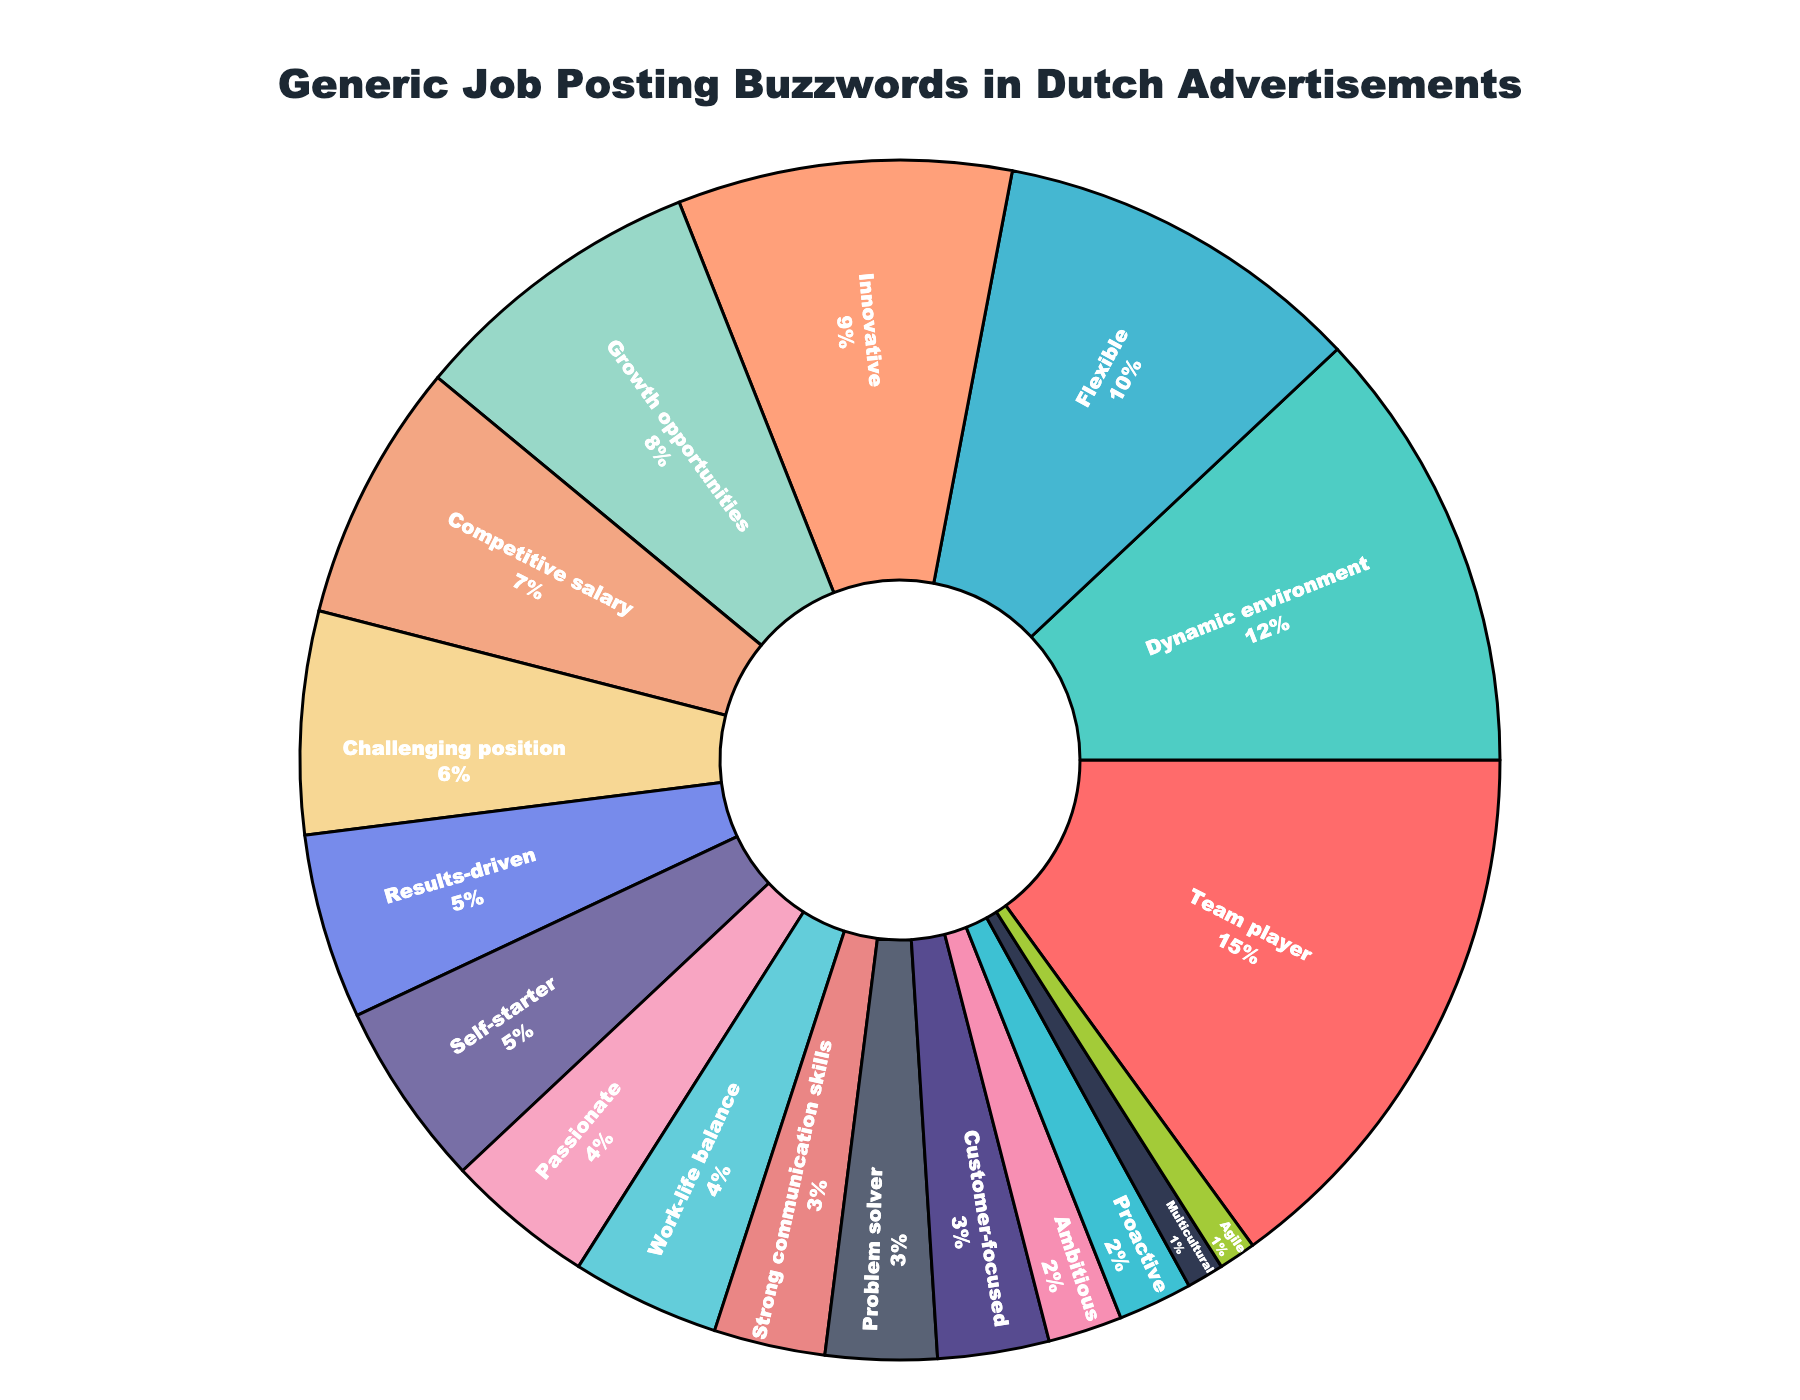What percentage of advertisements mentioned "Team player"? Locate the section of the pie chart labeled "Team player" and identify its corresponding percentage.
Answer: 15% Which buzzword is mentioned more often, "Problem solver" or "Multicultural"? Compare the percentages of "Problem solver" and "Multicultural" by finding and contrasting their respective sections in the pie chart. "Problem solver" is 3%, whereas "Multicultural" is 1%.
Answer: Problem solver How much higher is the percentage of "Dynamic environment" compared to "Proactive"? Subtract the percentage of "Proactive" (2%) from "Dynamic environment" (12%).
Answer: 10% What is the total percentage of advertisements using "Self-starter" and "Customer-focused"? Add the percentages for "Self-starter" (5%) and "Customer-focused" (3%).
Answer: 8% Rank the following buzzwords from most to least mentioned: "Competitive salary," "Innovative," "Ambitious." Compare the percentages: "Innovative" (9%), "Competitive salary" (7%), "Ambitious" (2%). Thus, the order is Innovative > Competitive salary > Ambitious.
Answer: Innovative > Competitive salary > Ambitious What is the combined percentage of the two least mentioned buzzwords? Add the percentages of the least mentioned buzzwords: "Agile" (1%) and "Multicultural" (1%).
Answer: 2% Which buzzword is used more frequently, "Challenging position" or "Growth opportunities," and by how much? Compare the percentages of "Challenging position" (6%) and "Growth opportunities" (8%) and subtract the smaller one from the larger one. Growth opportunities is higher by 8% - 6% = 2%.
Answer: Growth opportunities by 2% What is the total percentage of the three most frequently mentioned buzzwords? Add the percentages of the three highest buzzwords: "Team player" (15%), "Dynamic environment" (12%), and "Flexible" (10%). 15% + 12% + 10% = 37%.
Answer: 37% Which buzzword, colored blue, is used in 3% of advertisements? Locate the blue section in the pie chart labeled with 3%, which corresponds to "Customer-focused."
Answer: Customer-focused 